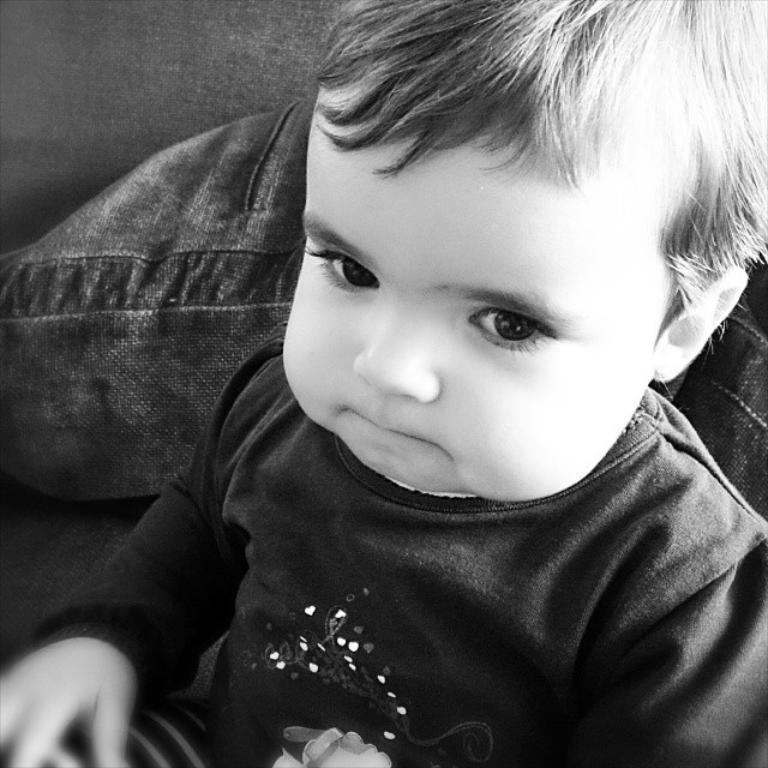What is the main subject of the image? The main subject of the image is a boy. What is the boy doing in the image? The boy is seated in the image. What is the color scheme of the image? The image is in black and white. What type of bait is the boy using to catch fish in the image? There is no indication of fishing or bait in the image; it only features a seated boy. 